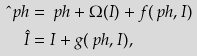<formula> <loc_0><loc_0><loc_500><loc_500>\hat { \ } p h & = \ p h + \Omega ( I ) + f ( \ p h , I ) \\ \hat { I } & = I + g ( \ p h , I ) ,</formula> 